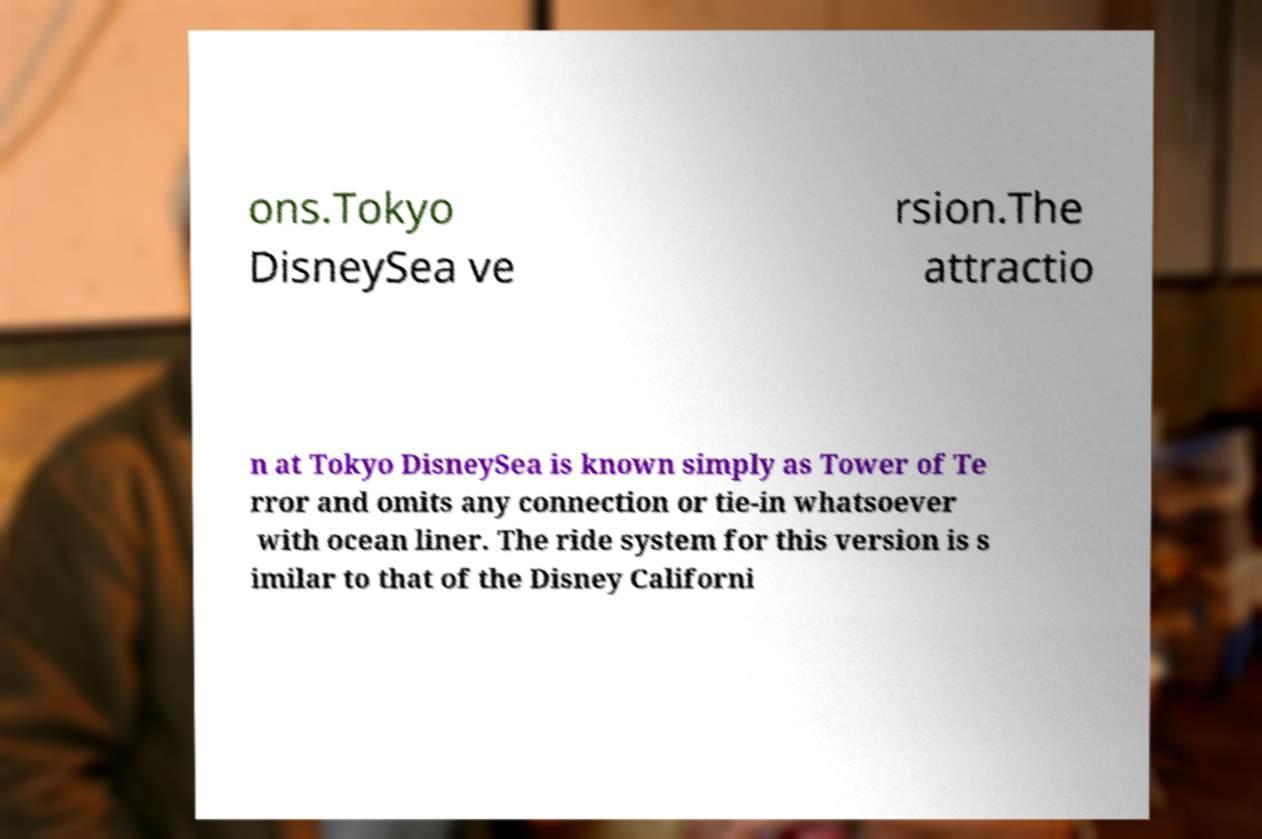Could you extract and type out the text from this image? ons.Tokyo DisneySea ve rsion.The attractio n at Tokyo DisneySea is known simply as Tower of Te rror and omits any connection or tie-in whatsoever with ocean liner. The ride system for this version is s imilar to that of the Disney Californi 